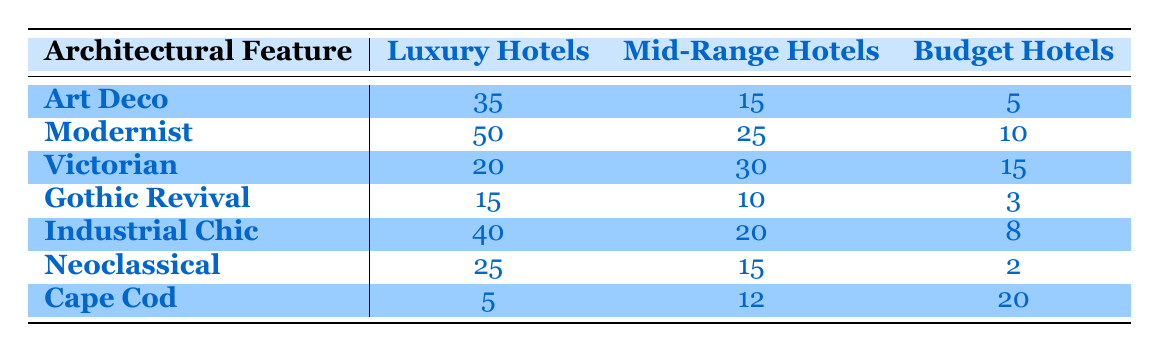What architectural feature has the highest number of luxury hotels? By examining the Luxury Hotels column, we can see that the Modernist architectural feature has the highest value with 50 luxury hotels, which is greater than the values of other features.
Answer: Modernist What is the total number of budget hotels across all architectural features? To find the total number of budget hotels, we add up the values in the Budget Hotels column: 5 (Art Deco) + 10 (Modernist) + 15 (Victorian) + 3 (Gothic Revival) + 8 (Industrial Chic) + 2 (Neoclassical) + 20 (Cape Cod) = 73.
Answer: 73 How many more mid-range hotels are associated with Victorian architecture than with Gothic Revival architecture? We compare the Mid-Range Hotels for both features: Victorian has 30, and Gothic Revival has 10. The difference is 30 - 10 = 20.
Answer: 20 Is it true that Cape Cod has more Budget Hotels than Neoclassical? Looking at the Budget Hotels counts, Cape Cod has 20 while Neoclassical has 2. Since 20 is greater than 2, the statement is true.
Answer: Yes What is the average number of luxury hotels for the architectural features listed? We find the average by adding all Luxury Hotels counts (35 + 50 + 20 + 15 + 40 + 25 + 5 = 190) and then dividing by the number of features, which is 7. So, 190 / 7 = 27.14.
Answer: 27.14 Which architectural feature combination has the least number of budget hotels? To find the least number of budget hotels, we can look across the Budget Hotels column. Gothic Revival has 3, which is the lowest value when compared to other features.
Answer: Gothic Revival What is the difference in the number of luxury hotels between Modernist and Art Deco? Modernist has 50 luxury hotels and Art Deco has 35. To find the difference, we subtract: 50 - 35 = 15.
Answer: 15 Which architectural feature has the least number of luxury hotels? By reviewing the Luxury Hotels column, we see that Cape Cod has the least number with a total of 5 luxury hotels.
Answer: Cape Cod 